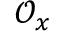<formula> <loc_0><loc_0><loc_500><loc_500>{ \mathcal { O } } _ { x }</formula> 